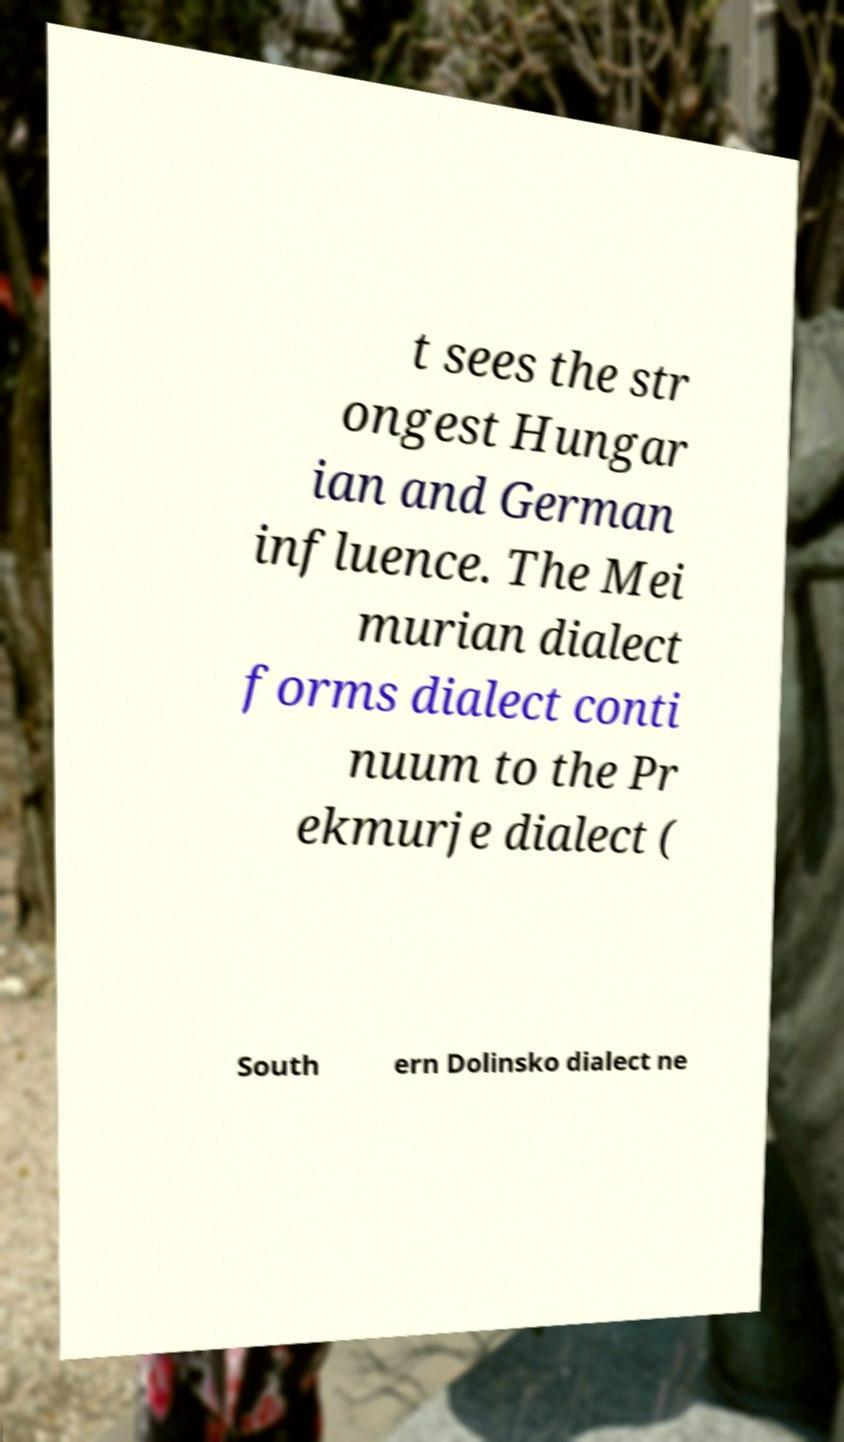I need the written content from this picture converted into text. Can you do that? t sees the str ongest Hungar ian and German influence. The Mei murian dialect forms dialect conti nuum to the Pr ekmurje dialect ( South ern Dolinsko dialect ne 